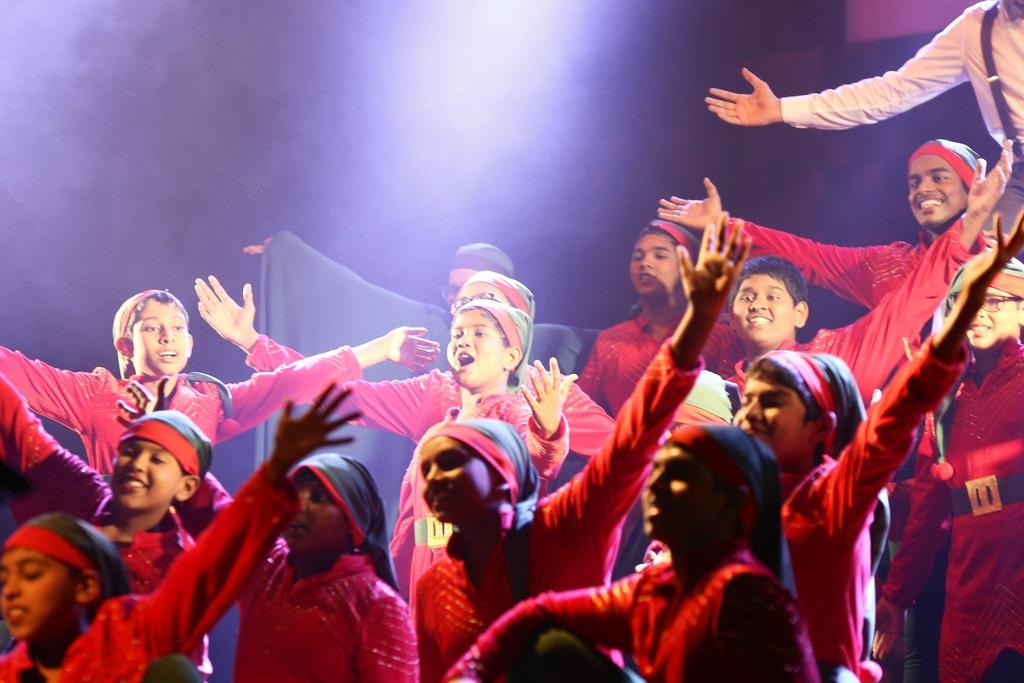Who or what can be seen in the image? There are people in the image. What are the people wearing in the image? The people are wearing costumes. How many deer are present in the image? There are no deer present in the image; it features people wearing costumes. What type of committee can be seen in the image? There is no committee present in the image; it features people wearing costumes. 